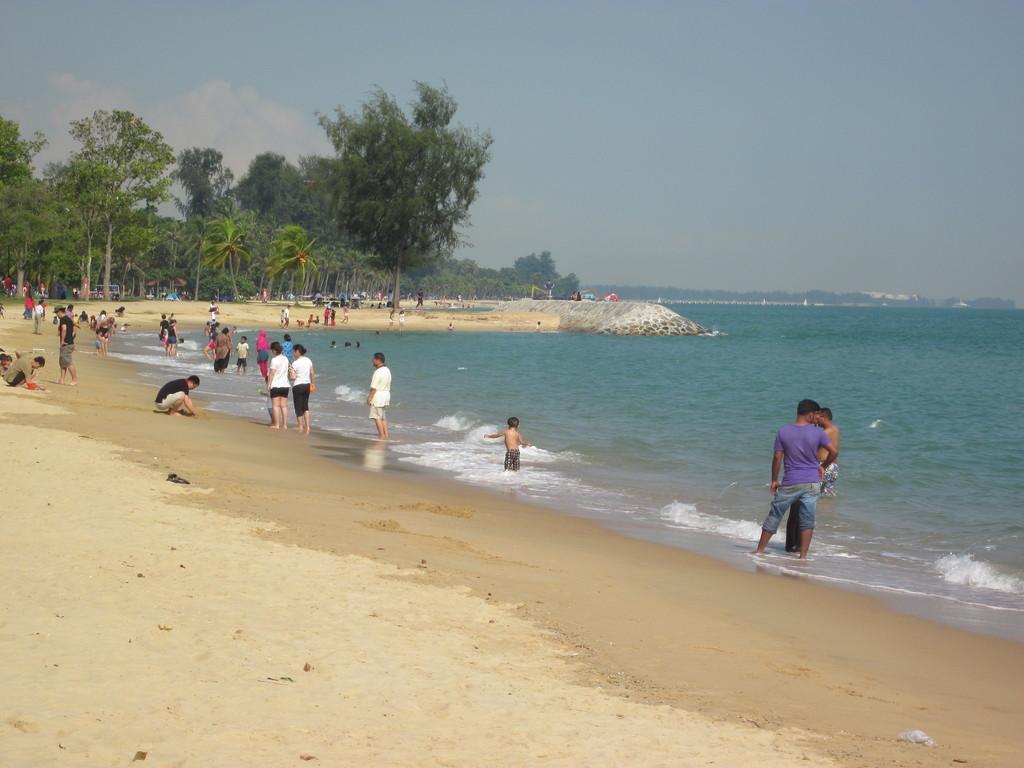Can you describe this image briefly? In this image on the right side there is a beach and on the left side there are some persons. In the background there are some trees, and at the top of the image there is sky and at the bottom there is sand. 